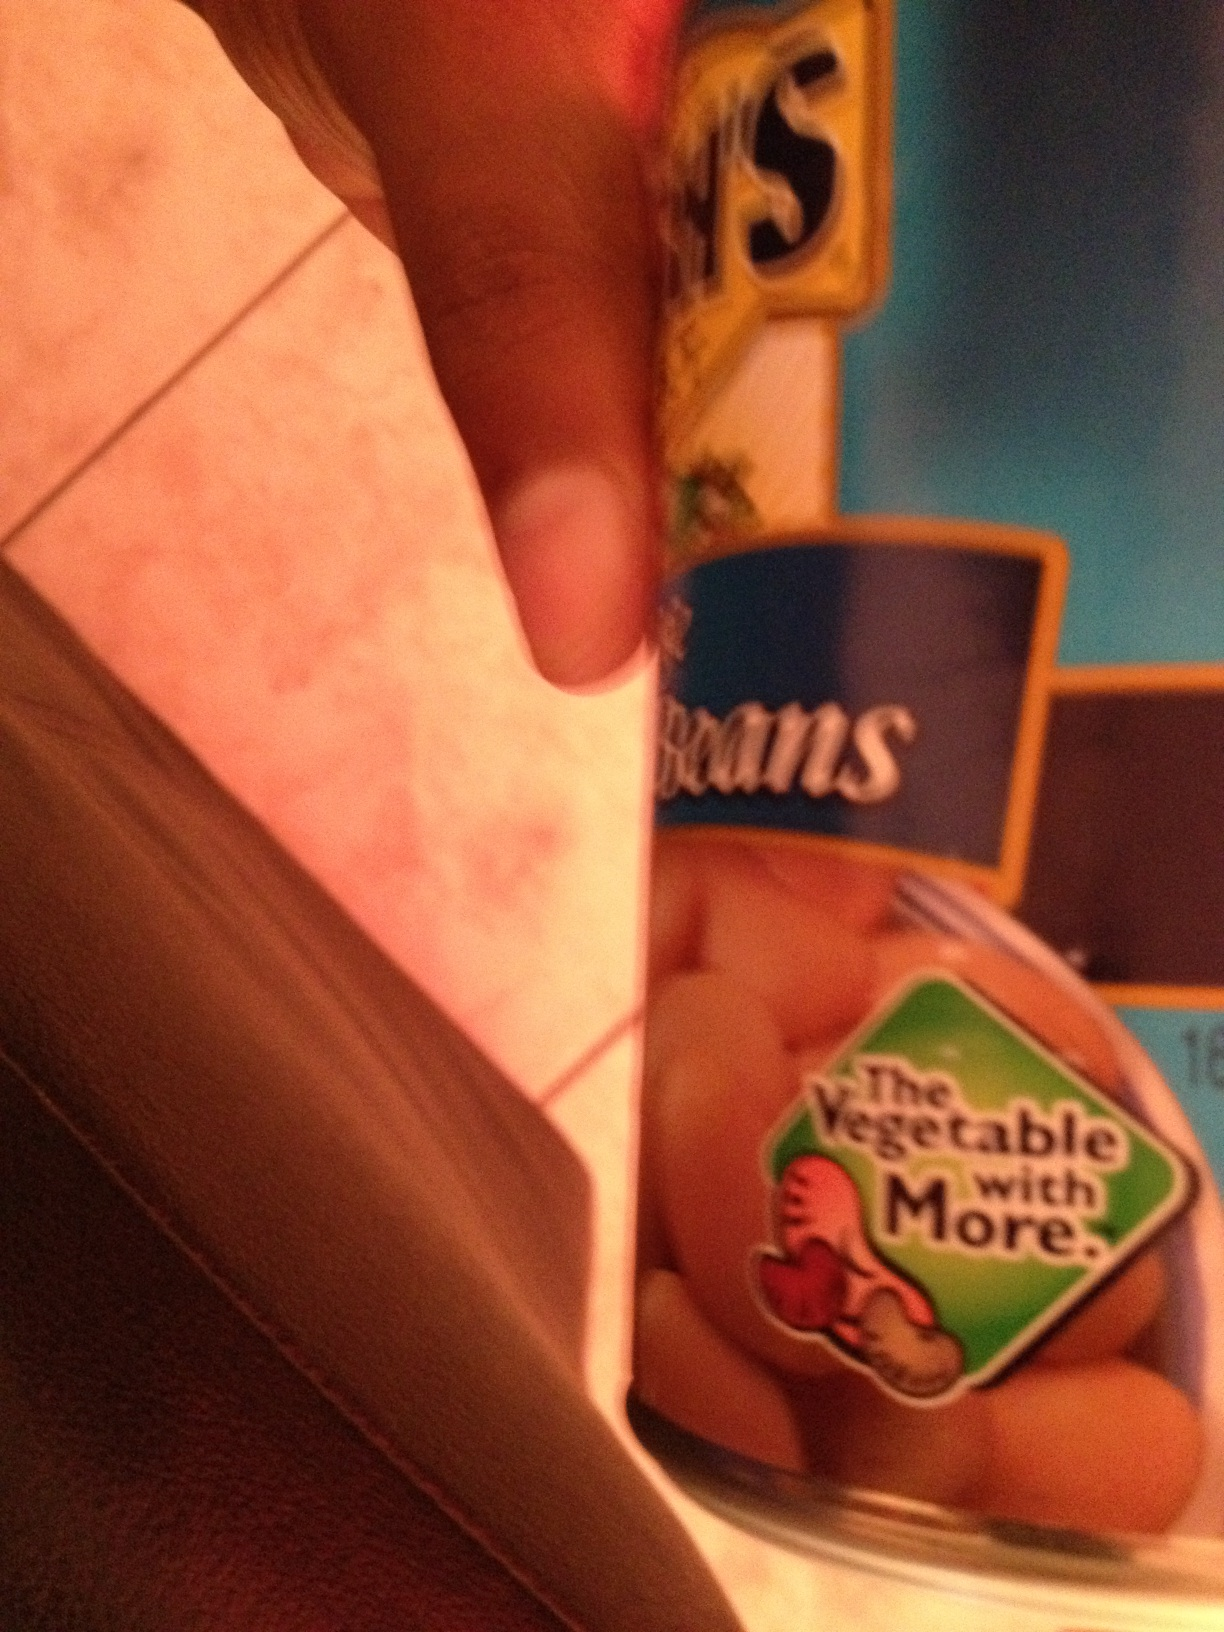What are the nutritional benefits of eating pinto beans? Pinto beans are very nutritious. They are an excellent source of protein, which is crucial for muscle repair and growth. They also contain dietary fiber, which helps with digestion and can improve cholesterol levels. Additionally, they are rich in vitamins and minerals like B vitamins, iron, magnesium, and potassium. 